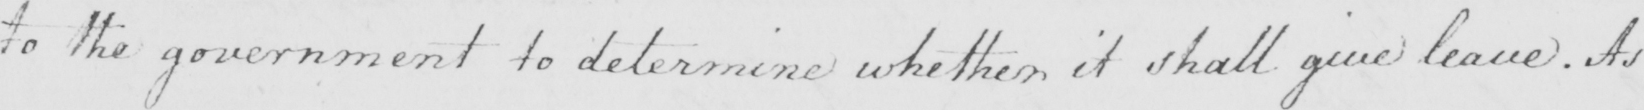Transcribe the text shown in this historical manuscript line. to the government to determine whether it shall give leave . As 